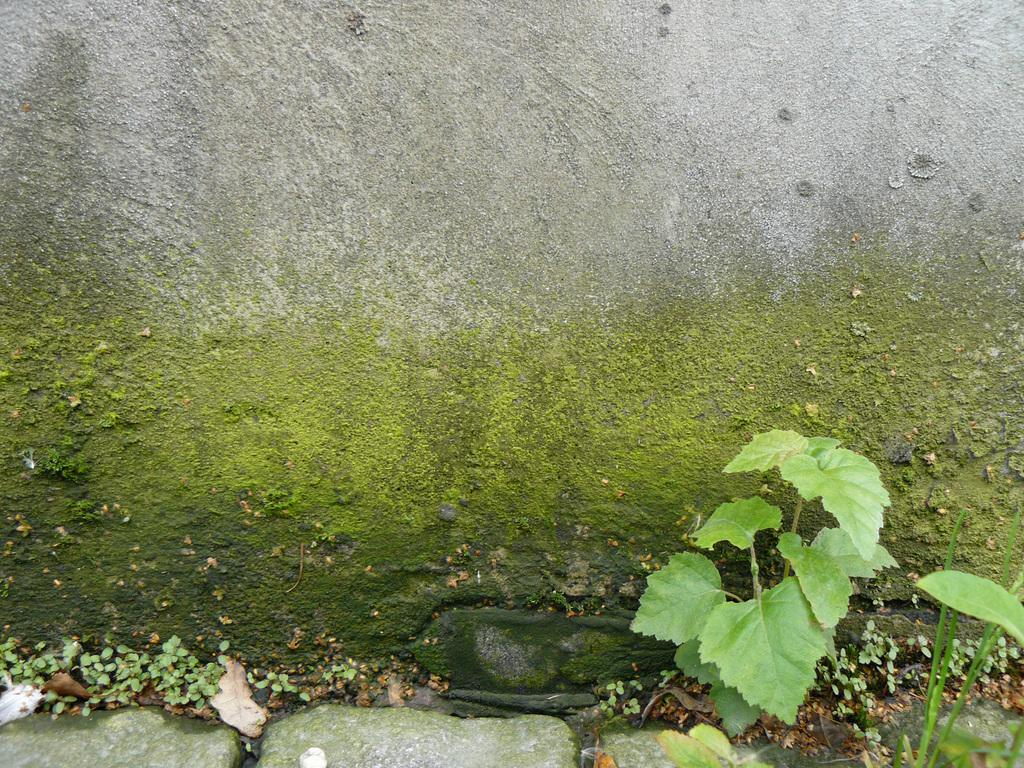What type of growth can be seen on the wall in the image? There is moss on the wall in the image. What other living organisms are present in the image? There are plants in the image. What type of liquid is being kicked in the image? There is no liquid or kicking action present in the image. 